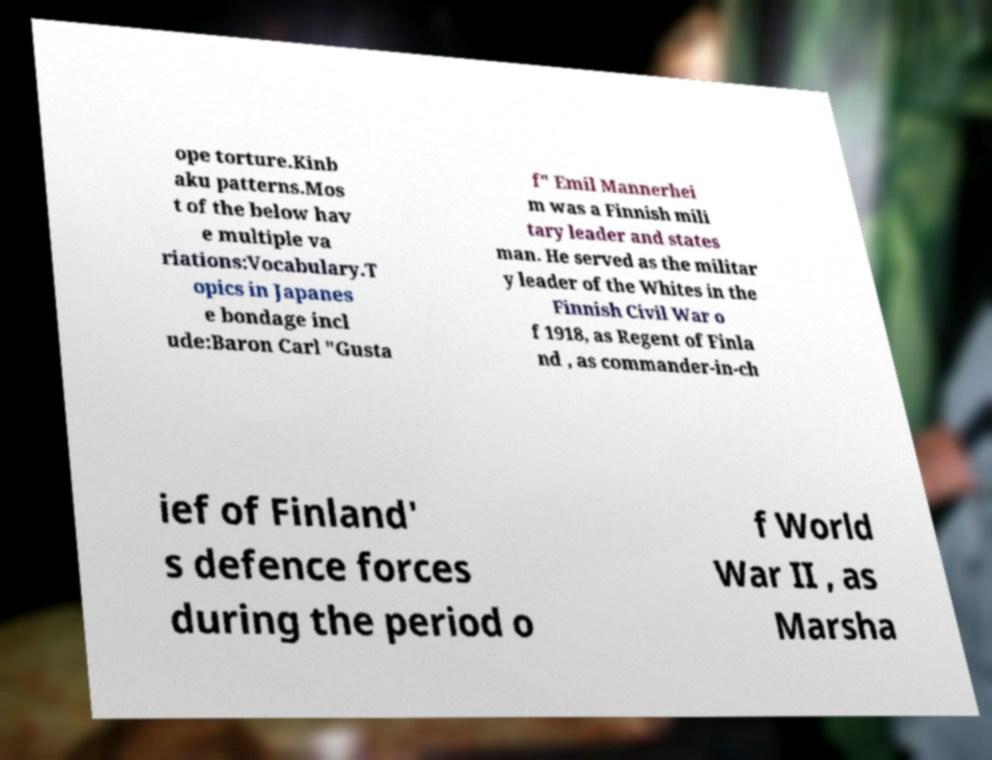Could you extract and type out the text from this image? ope torture.Kinb aku patterns.Mos t of the below hav e multiple va riations:Vocabulary.T opics in Japanes e bondage incl ude:Baron Carl "Gusta f" Emil Mannerhei m was a Finnish mili tary leader and states man. He served as the militar y leader of the Whites in the Finnish Civil War o f 1918, as Regent of Finla nd , as commander-in-ch ief of Finland' s defence forces during the period o f World War II , as Marsha 